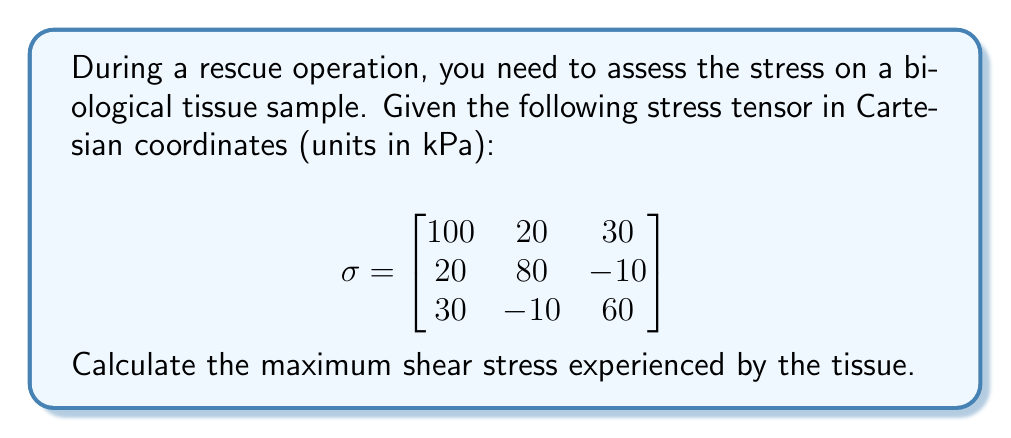Teach me how to tackle this problem. To find the maximum shear stress, we need to follow these steps:

1) First, we need to calculate the principal stresses. These are the eigenvalues of the stress tensor.

2) The characteristic equation for the eigenvalues is:
   $$\det(\sigma - \lambda I) = 0$$

3) Expanding this determinant:
   $$\begin{vmatrix}
   100-\lambda & 20 & 30 \\
   20 & 80-\lambda & -10 \\
   30 & -10 & 60-\lambda
   \end{vmatrix} = 0$$

4) This leads to the cubic equation:
   $$-\lambda^3 + 240\lambda^2 - 17900\lambda + 416000 = 0$$

5) Solving this equation (using a calculator or computer algebra system) gives the principal stresses:
   $$\lambda_1 \approx 122.76 \text{ kPa}$$
   $$\lambda_2 \approx 83.78 \text{ kPa}$$
   $$\lambda_3 \approx 33.46 \text{ kPa}$$

6) The maximum shear stress $\tau_{max}$ is given by half the difference between the largest and smallest principal stresses:

   $$\tau_{max} = \frac{\lambda_{max} - \lambda_{min}}{2} = \frac{\lambda_1 - \lambda_3}{2}$$

7) Substituting the values:
   $$\tau_{max} = \frac{122.76 - 33.46}{2} = 44.65 \text{ kPa}$$

Therefore, the maximum shear stress experienced by the tissue is approximately 44.65 kPa.
Answer: $44.65 \text{ kPa}$ 